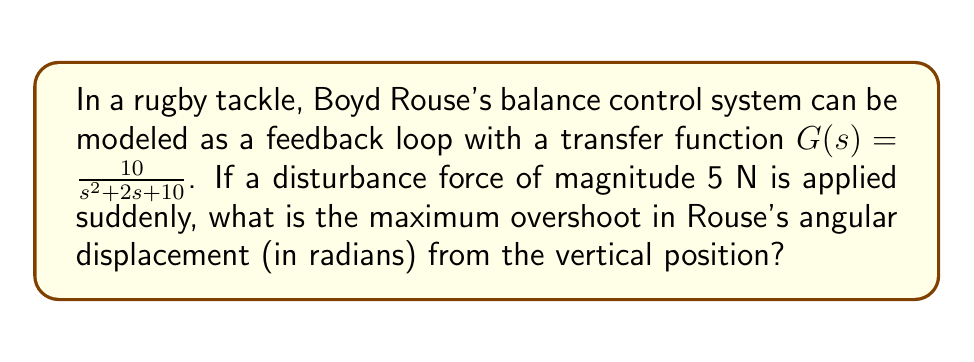Can you solve this math problem? To solve this problem, we need to follow these steps:

1) The transfer function $G(s) = \frac{10}{s^2 + 2s + 10}$ is in the form of a second-order system:

   $$G(s) = \frac{\omega_n^2}{s^2 + 2\zeta\omega_n s + \omega_n^2}$$

   Where $\omega_n$ is the natural frequency and $\zeta$ is the damping ratio.

2) From our transfer function, we can identify:
   $\omega_n^2 = 10$, so $\omega_n = \sqrt{10}$
   $2\zeta\omega_n = 2$, so $\zeta = \frac{2}{2\sqrt{10}} = \frac{1}{\sqrt{10}}$

3) The maximum overshoot for a second-order system is given by:

   $$M_p = e^{-\frac{\zeta\pi}{\sqrt{1-\zeta^2}}}$$

4) Substituting our $\zeta$ value:

   $$M_p = e^{-\frac{\frac{1}{\sqrt{10}}\pi}{\sqrt{1-(\frac{1}{\sqrt{10}})^2}}} = e^{-\frac{\pi}{\sqrt{9}}} = e^{-\frac{\pi}{3}}$$

5) The overshoot percentage is:

   $$\text{Overshoot} = M_p \times 100\% = e^{-\frac{\pi}{3}} \times 100\% \approx 35.12\%$$

6) The steady-state value for a step input of magnitude 5 is:

   $$y_{ss} = 5 \times G(0) = 5 \times \frac{10}{10} = 5$$

7) The maximum overshoot in absolute terms is:

   $$\text{Max Overshoot} = y_{ss} \times (1 + \text{Overshoot}) = 5 \times (1 + 0.3512) = 6.756$$

8) The maximum angular displacement is therefore 6.756 radians.
Answer: The maximum overshoot in Boyd Rouse's angular displacement is approximately 6.756 radians. 